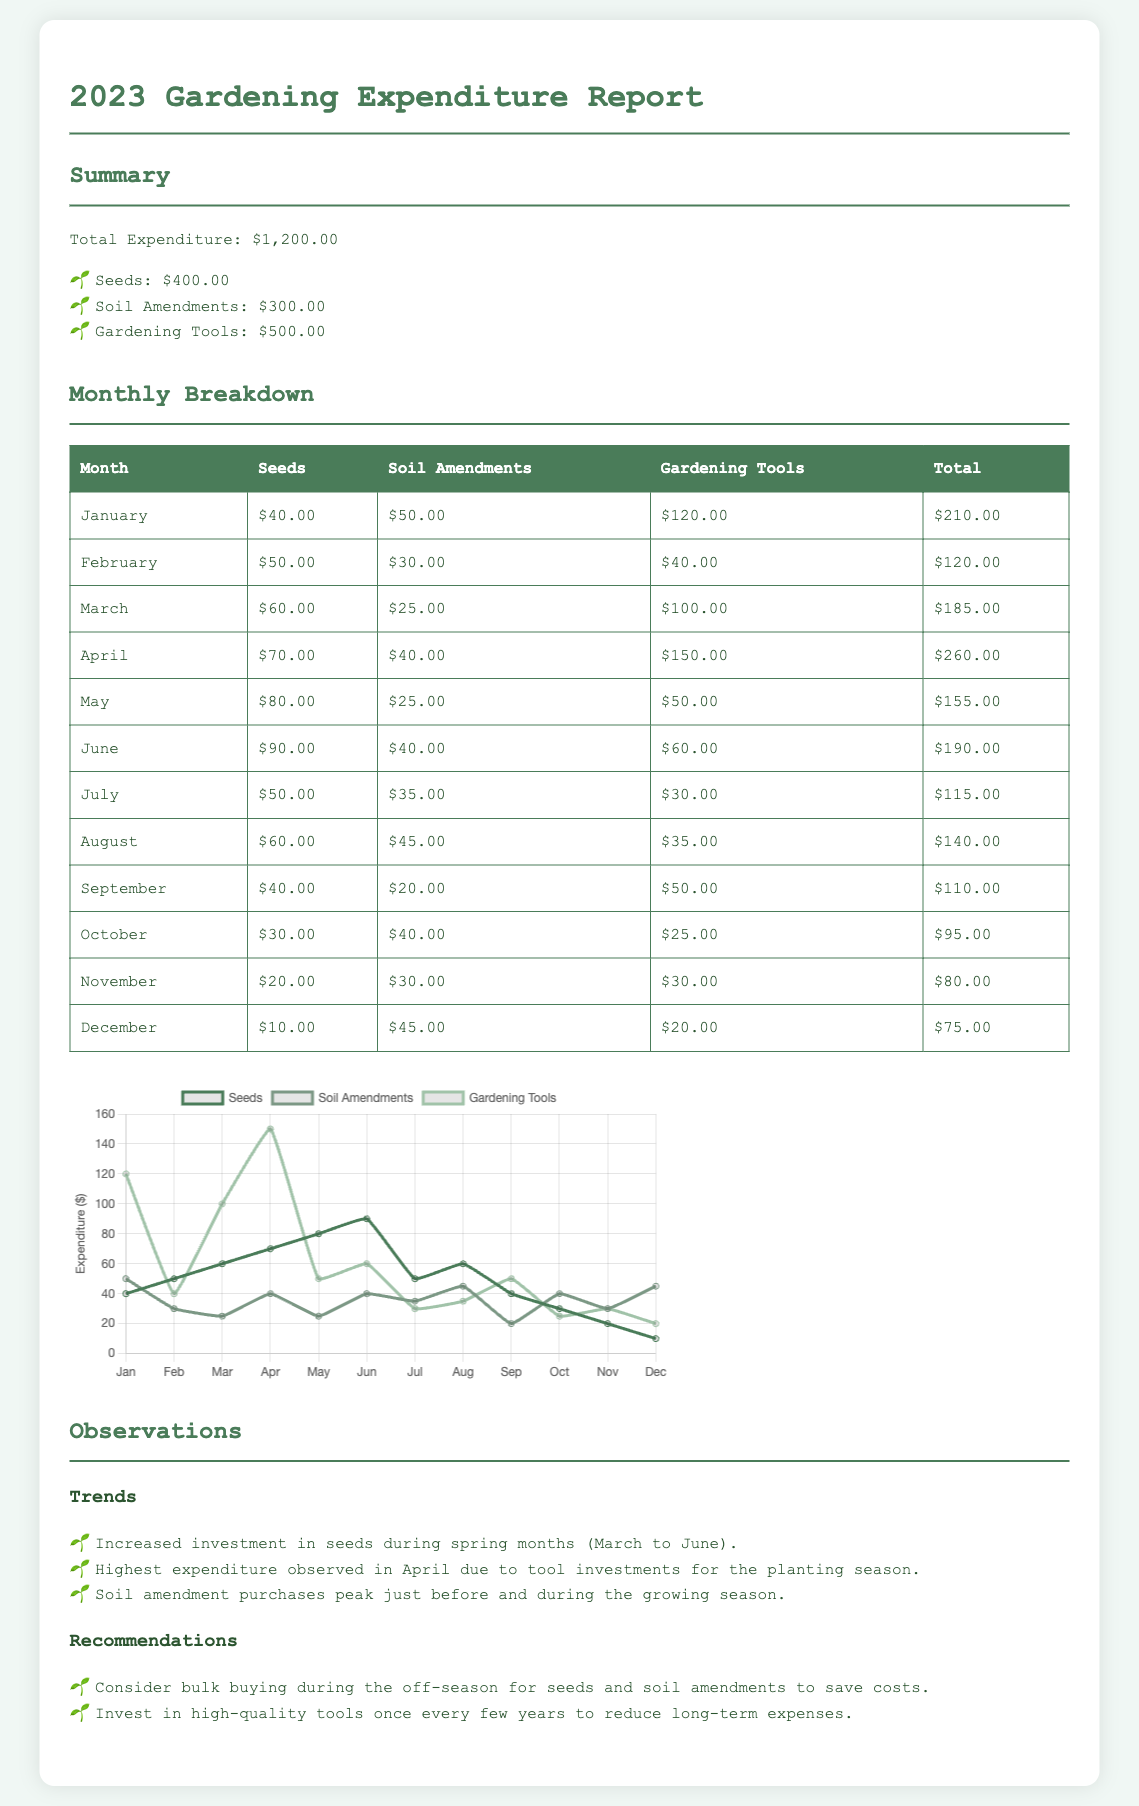what is the total expenditure for the year 2023? The total expenditure is the sum of expenditures on seeds, soil amendments, and gardening tools, which equals $1,200.00.
Answer: $1,200.00 how much was spent on soil amendments? The expenditure on soil amendments is specifically mentioned in the summary section.
Answer: $300.00 which month had the highest expenditure? The monthly breakdown indicates that April had the highest total expenditure of $260.00.
Answer: April what were the seed purchases in March? The monthly details table shows that seed purchases in March were $60.00.
Answer: $60.00 how much was invested in gardening tools in November? The monthly breakdown specifies that gardening tools investment in November was $30.00.
Answer: $30.00 what trend is observed regarding seed purchases? The observations section notes that there was an increased investment in seeds during spring months, specifically March to June.
Answer: Increased investment in spring how much total expenditure was allocated to gardening tools throughout the year? The summary lists the total expenditure for gardening tools as $500.00.
Answer: $500.00 which months had soil amendment expenditures exceeding $40.00? Referring to the monthly details, the months with soil amendment expenditures exceeding $40.00 are January, April, August, and December.
Answer: January, April, August, December what is a recommendation for purchasing seeds and soil amendments? The recommendations state that bulk buying during the off-season is advised to save costs.
Answer: Bulk buying during off-season 